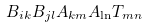<formula> <loc_0><loc_0><loc_500><loc_500>B _ { i k } B _ { j l } A _ { k m } A _ { \ln } T _ { m n }</formula> 